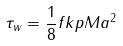Convert formula to latex. <formula><loc_0><loc_0><loc_500><loc_500>\tau _ { w } = \frac { 1 } { 8 } f k p M a ^ { 2 }</formula> 